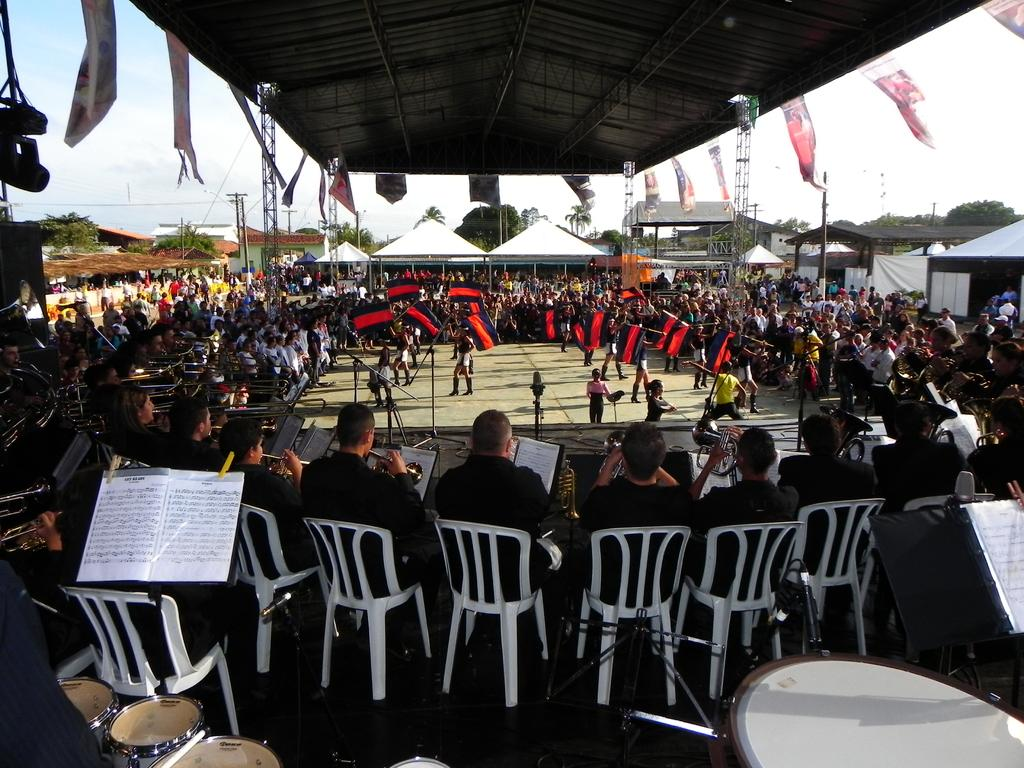What are the people in the image doing? The people in the image are sitting on chairs. What can be seen on the roof in the image? There are posters on the roof. What type of structures are present around the chairs? There are bands and other tents around. What is the price of the humor in the image? There is no humor present in the image, nor is there any indication of a price. 